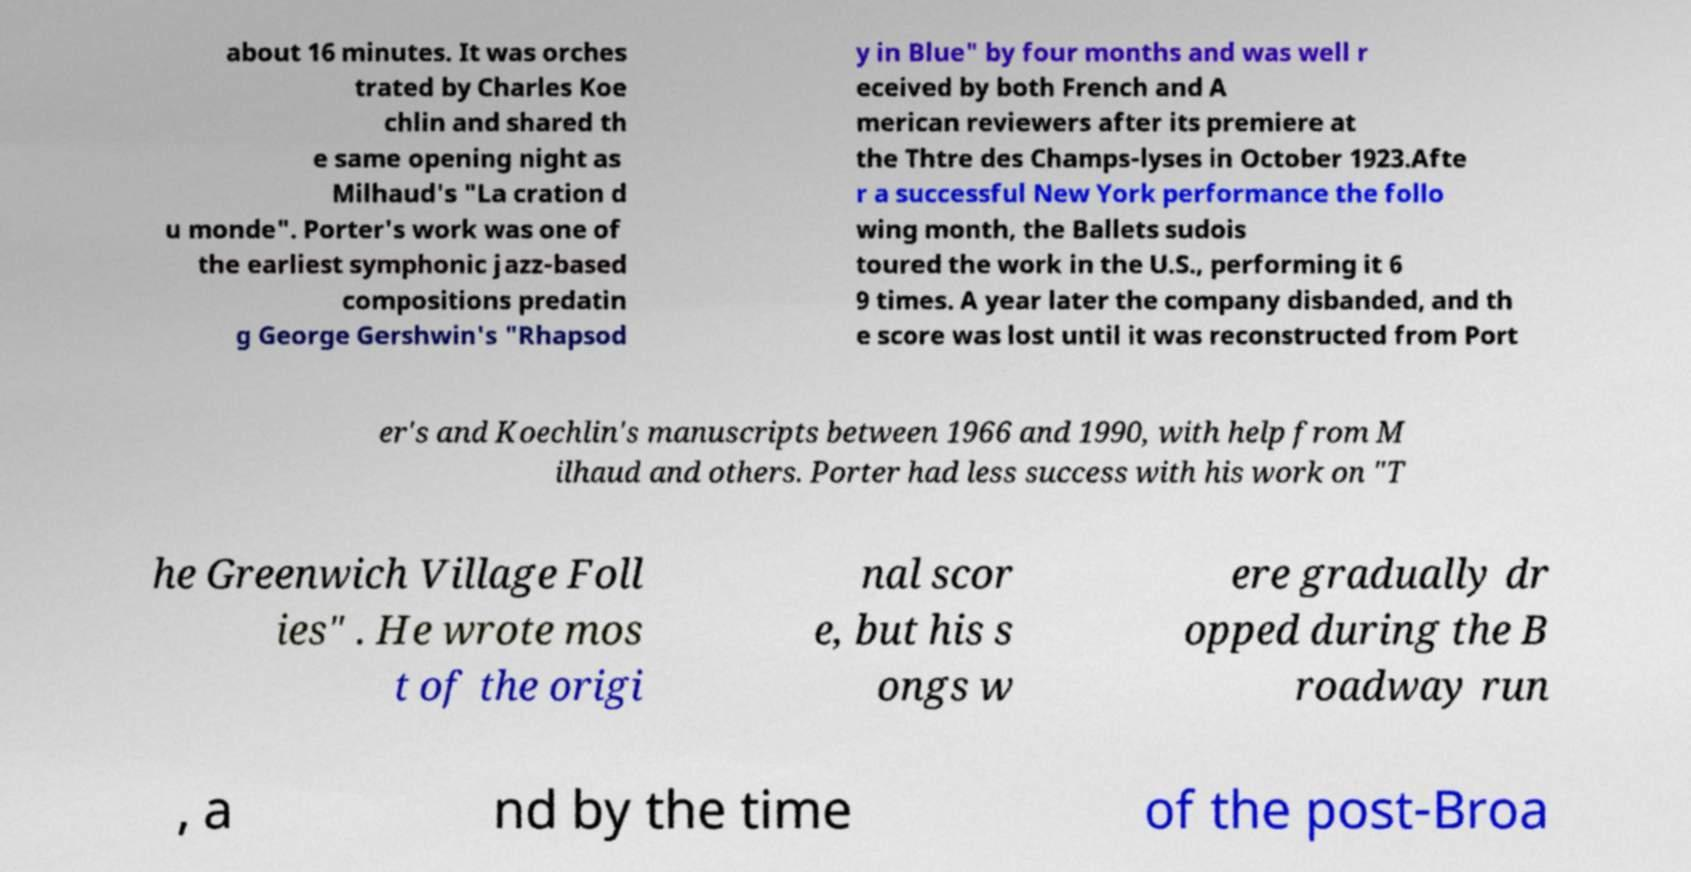Please identify and transcribe the text found in this image. about 16 minutes. It was orches trated by Charles Koe chlin and shared th e same opening night as Milhaud's "La cration d u monde". Porter's work was one of the earliest symphonic jazz-based compositions predatin g George Gershwin's "Rhapsod y in Blue" by four months and was well r eceived by both French and A merican reviewers after its premiere at the Thtre des Champs-lyses in October 1923.Afte r a successful New York performance the follo wing month, the Ballets sudois toured the work in the U.S., performing it 6 9 times. A year later the company disbanded, and th e score was lost until it was reconstructed from Port er's and Koechlin's manuscripts between 1966 and 1990, with help from M ilhaud and others. Porter had less success with his work on "T he Greenwich Village Foll ies" . He wrote mos t of the origi nal scor e, but his s ongs w ere gradually dr opped during the B roadway run , a nd by the time of the post-Broa 